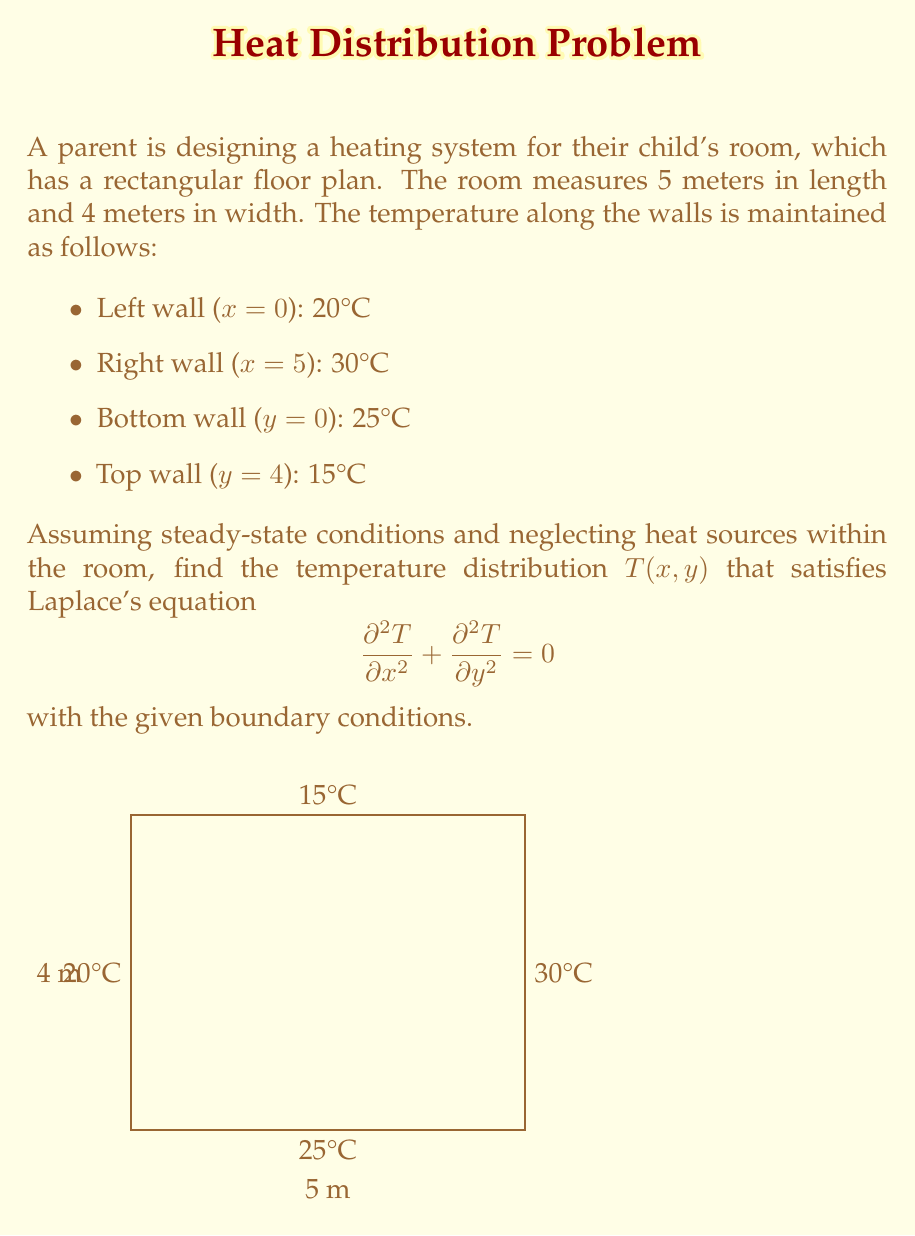Can you answer this question? To solve this problem, we'll use the method of separation of variables:

1) Assume the solution has the form: $T(x,y) = X(x)Y(y)$

2) Substitute into Laplace's equation:
   $$Y\frac{d^2X}{dx^2} + X\frac{d^2Y}{dy^2} = 0$$

3) Divide by XY:
   $$\frac{1}{X}\frac{d^2X}{dx^2} + \frac{1}{Y}\frac{d^2Y}{dy^2} = 0$$

4) Separate variables:
   $$\frac{1}{X}\frac{d^2X}{dx^2} = -\frac{1}{Y}\frac{d^2Y}{dy^2} = -\lambda^2$$

5) Solve the resulting ODEs:
   $X(x) = A\cos(\lambda x) + B\sin(\lambda x)$
   $Y(y) = C\cosh(\lambda y) + D\sinh(\lambda y)$

6) Apply boundary conditions:
   $X(0) = 20$, $X(5) = 30$
   $Y(0) = 25$, $Y(4) = 15$

7) The general solution that satisfies these conditions is:
   $$T(x,y) = 20 + 2x + 25 - \frac{5y}{2} + \sum_{n=1}^{\infty} A_n \sin(\frac{n\pi x}{5}) \sinh(\frac{n\pi y}{5})$$

8) The coefficients $A_n$ are found using Fourier series:
   $$A_n = \frac{2}{5\sinh(\frac{4n\pi}{5})} \int_0^5 [f(x) - (20 + 2x)] \sin(\frac{n\pi x}{5}) dx$$

   where $f(x) = 30$ when $x = 5$, and $f(x) = 20$ when $x = 0$

9) Evaluating this integral:
   $$A_n = \frac{20}{n\pi\sinh(\frac{4n\pi}{5})} [1 - (-1)^n]$$

Therefore, the temperature distribution is given by the infinite series solution in step 7 with coefficients from step 9.
Answer: $$T(x,y) = 20 + 2x + 25 - \frac{5y}{2} + \sum_{n=1}^{\infty} \frac{20}{n\pi\sinh(\frac{4n\pi}{5})} [1 - (-1)^n] \sin(\frac{n\pi x}{5}) \sinh(\frac{n\pi y}{5})$$ 